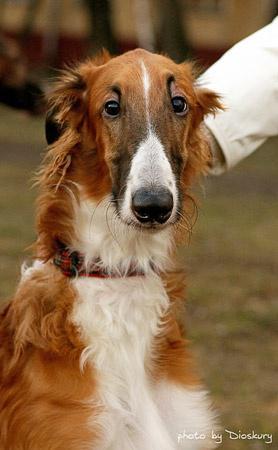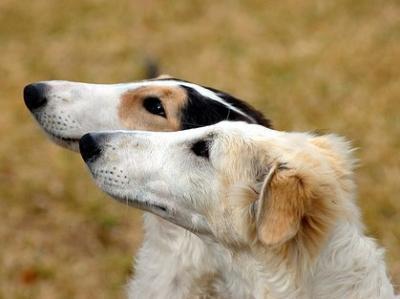The first image is the image on the left, the second image is the image on the right. Examine the images to the left and right. Is the description "The left image is a profile with the dog facing right." accurate? Answer yes or no. No. 